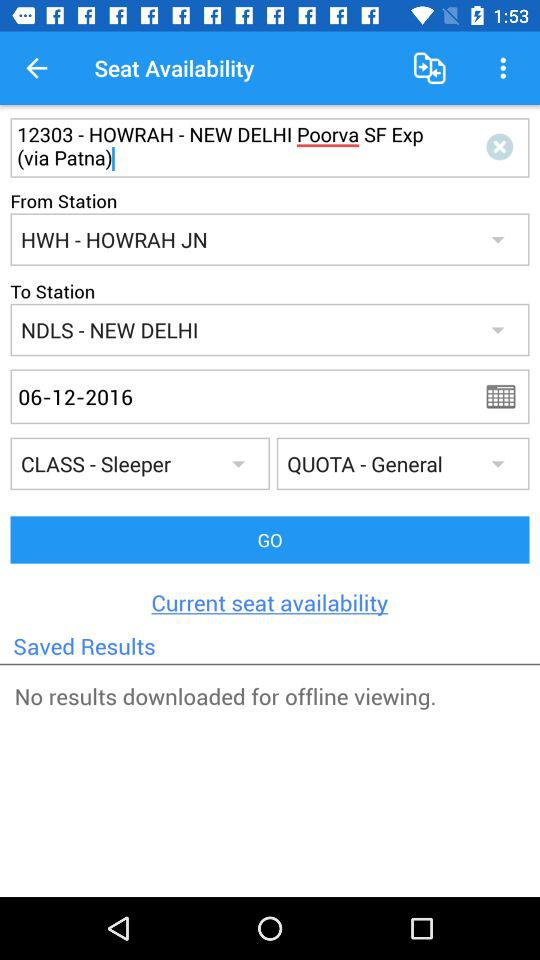What flight class is the ticket for? The ticket is for sleeper class. 